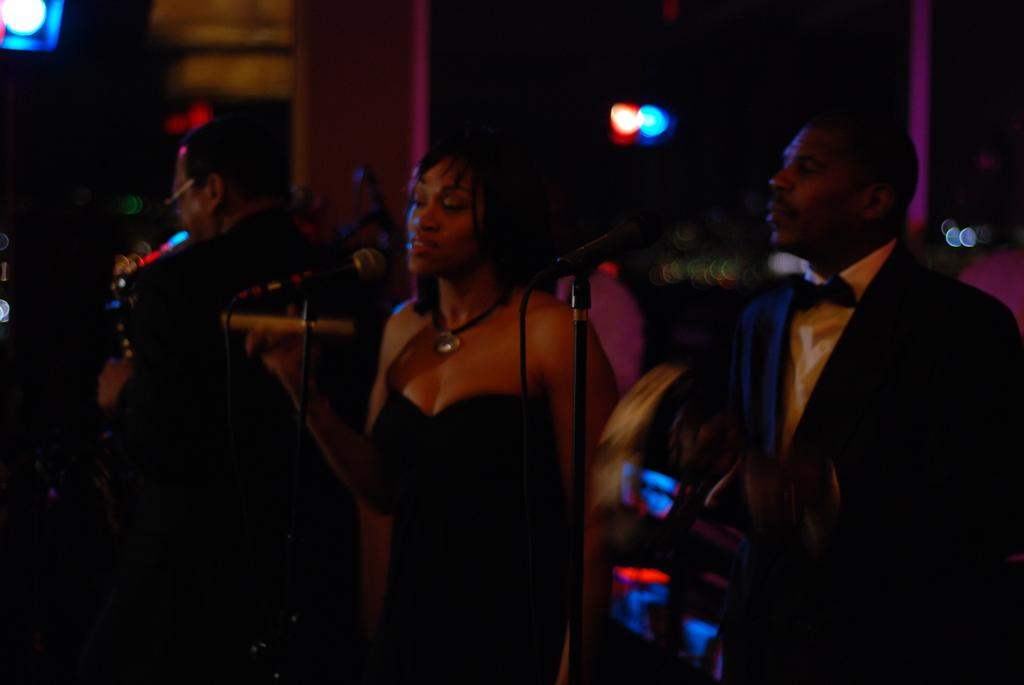How many people are in the image? There are two people in the image. What are the microphones used for in the image? The microphones are in front of the two people, suggesting they might be used for recording or amplifying their voices. What can be seen in the image that might be used for lighting purposes? There are focusing lights in the image. What is the man in the image doing? A man is playing a musical instrument in the image. What type of polish is the man applying to the tiger in the image? There is no tiger or polish present in the image. What is the relation between the two people in the image? The provided facts do not give any information about the relationship between the two people in the image. 